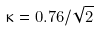<formula> <loc_0><loc_0><loc_500><loc_500>\kappa = 0 . 7 6 / \sqrt { 2 }</formula> 